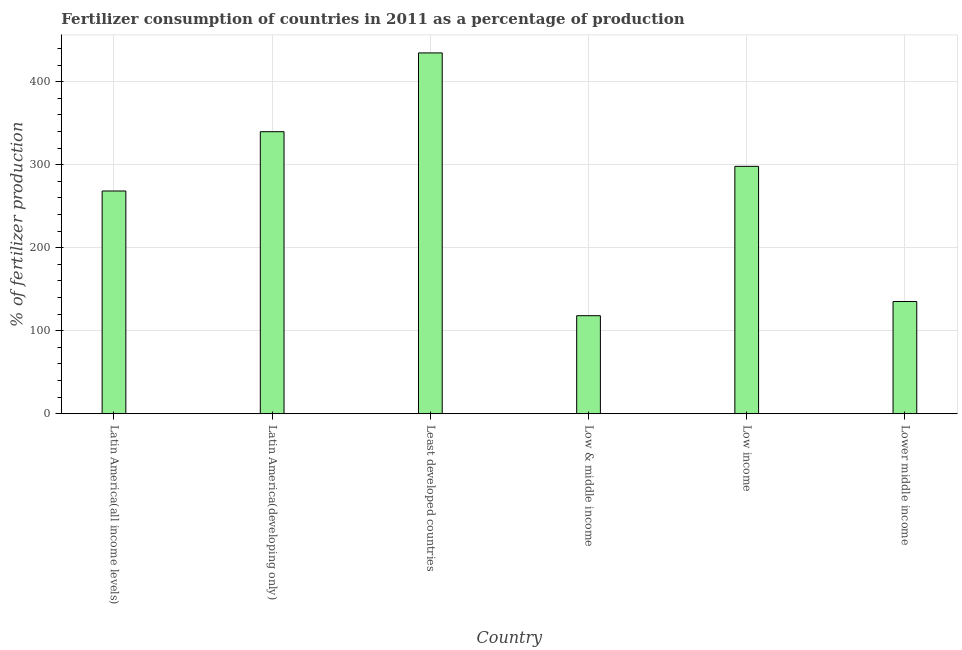What is the title of the graph?
Provide a short and direct response. Fertilizer consumption of countries in 2011 as a percentage of production. What is the label or title of the X-axis?
Offer a terse response. Country. What is the label or title of the Y-axis?
Your answer should be very brief. % of fertilizer production. What is the amount of fertilizer consumption in Latin America(all income levels)?
Keep it short and to the point. 268.3. Across all countries, what is the maximum amount of fertilizer consumption?
Offer a very short reply. 434.64. Across all countries, what is the minimum amount of fertilizer consumption?
Provide a succinct answer. 118.1. In which country was the amount of fertilizer consumption maximum?
Your response must be concise. Least developed countries. In which country was the amount of fertilizer consumption minimum?
Offer a terse response. Low & middle income. What is the sum of the amount of fertilizer consumption?
Your response must be concise. 1593.94. What is the difference between the amount of fertilizer consumption in Latin America(all income levels) and Latin America(developing only)?
Provide a succinct answer. -71.44. What is the average amount of fertilizer consumption per country?
Your answer should be very brief. 265.66. What is the median amount of fertilizer consumption?
Your answer should be very brief. 283.15. In how many countries, is the amount of fertilizer consumption greater than 380 %?
Give a very brief answer. 1. What is the ratio of the amount of fertilizer consumption in Latin America(all income levels) to that in Lower middle income?
Ensure brevity in your answer.  1.99. Is the amount of fertilizer consumption in Low & middle income less than that in Lower middle income?
Provide a short and direct response. Yes. What is the difference between the highest and the second highest amount of fertilizer consumption?
Offer a very short reply. 94.89. What is the difference between the highest and the lowest amount of fertilizer consumption?
Your response must be concise. 316.54. In how many countries, is the amount of fertilizer consumption greater than the average amount of fertilizer consumption taken over all countries?
Keep it short and to the point. 4. How many bars are there?
Ensure brevity in your answer.  6. Are all the bars in the graph horizontal?
Offer a very short reply. No. How many countries are there in the graph?
Provide a short and direct response. 6. What is the difference between two consecutive major ticks on the Y-axis?
Offer a very short reply. 100. Are the values on the major ticks of Y-axis written in scientific E-notation?
Provide a succinct answer. No. What is the % of fertilizer production in Latin America(all income levels)?
Provide a succinct answer. 268.3. What is the % of fertilizer production in Latin America(developing only)?
Provide a succinct answer. 339.75. What is the % of fertilizer production in Least developed countries?
Give a very brief answer. 434.64. What is the % of fertilizer production in Low & middle income?
Give a very brief answer. 118.1. What is the % of fertilizer production of Low income?
Keep it short and to the point. 297.99. What is the % of fertilizer production in Lower middle income?
Your answer should be compact. 135.17. What is the difference between the % of fertilizer production in Latin America(all income levels) and Latin America(developing only)?
Offer a terse response. -71.44. What is the difference between the % of fertilizer production in Latin America(all income levels) and Least developed countries?
Your response must be concise. -166.33. What is the difference between the % of fertilizer production in Latin America(all income levels) and Low & middle income?
Give a very brief answer. 150.21. What is the difference between the % of fertilizer production in Latin America(all income levels) and Low income?
Keep it short and to the point. -29.69. What is the difference between the % of fertilizer production in Latin America(all income levels) and Lower middle income?
Ensure brevity in your answer.  133.14. What is the difference between the % of fertilizer production in Latin America(developing only) and Least developed countries?
Ensure brevity in your answer.  -94.89. What is the difference between the % of fertilizer production in Latin America(developing only) and Low & middle income?
Give a very brief answer. 221.65. What is the difference between the % of fertilizer production in Latin America(developing only) and Low income?
Your answer should be compact. 41.75. What is the difference between the % of fertilizer production in Latin America(developing only) and Lower middle income?
Give a very brief answer. 204.58. What is the difference between the % of fertilizer production in Least developed countries and Low & middle income?
Provide a succinct answer. 316.54. What is the difference between the % of fertilizer production in Least developed countries and Low income?
Provide a succinct answer. 136.64. What is the difference between the % of fertilizer production in Least developed countries and Lower middle income?
Make the answer very short. 299.47. What is the difference between the % of fertilizer production in Low & middle income and Low income?
Provide a short and direct response. -179.9. What is the difference between the % of fertilizer production in Low & middle income and Lower middle income?
Your answer should be very brief. -17.07. What is the difference between the % of fertilizer production in Low income and Lower middle income?
Ensure brevity in your answer.  162.83. What is the ratio of the % of fertilizer production in Latin America(all income levels) to that in Latin America(developing only)?
Keep it short and to the point. 0.79. What is the ratio of the % of fertilizer production in Latin America(all income levels) to that in Least developed countries?
Your answer should be very brief. 0.62. What is the ratio of the % of fertilizer production in Latin America(all income levels) to that in Low & middle income?
Give a very brief answer. 2.27. What is the ratio of the % of fertilizer production in Latin America(all income levels) to that in Lower middle income?
Your answer should be compact. 1.99. What is the ratio of the % of fertilizer production in Latin America(developing only) to that in Least developed countries?
Make the answer very short. 0.78. What is the ratio of the % of fertilizer production in Latin America(developing only) to that in Low & middle income?
Provide a short and direct response. 2.88. What is the ratio of the % of fertilizer production in Latin America(developing only) to that in Low income?
Offer a terse response. 1.14. What is the ratio of the % of fertilizer production in Latin America(developing only) to that in Lower middle income?
Provide a succinct answer. 2.51. What is the ratio of the % of fertilizer production in Least developed countries to that in Low & middle income?
Ensure brevity in your answer.  3.68. What is the ratio of the % of fertilizer production in Least developed countries to that in Low income?
Make the answer very short. 1.46. What is the ratio of the % of fertilizer production in Least developed countries to that in Lower middle income?
Give a very brief answer. 3.22. What is the ratio of the % of fertilizer production in Low & middle income to that in Low income?
Provide a short and direct response. 0.4. What is the ratio of the % of fertilizer production in Low & middle income to that in Lower middle income?
Make the answer very short. 0.87. What is the ratio of the % of fertilizer production in Low income to that in Lower middle income?
Offer a terse response. 2.21. 